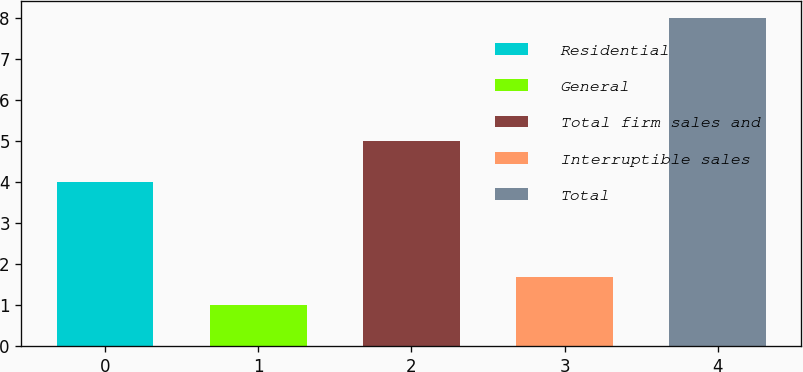Convert chart. <chart><loc_0><loc_0><loc_500><loc_500><bar_chart><fcel>Residential<fcel>General<fcel>Total firm sales and<fcel>Interruptible sales<fcel>Total<nl><fcel>4<fcel>1<fcel>5<fcel>1.7<fcel>8<nl></chart> 